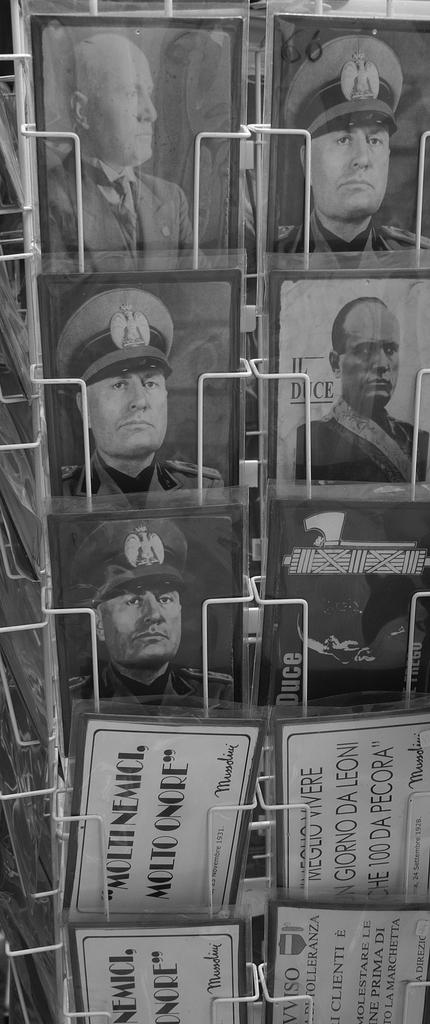<image>
Describe the image concisely. Photos of various men in black and white and signs saying Moltinemici Molto Onore and others. 